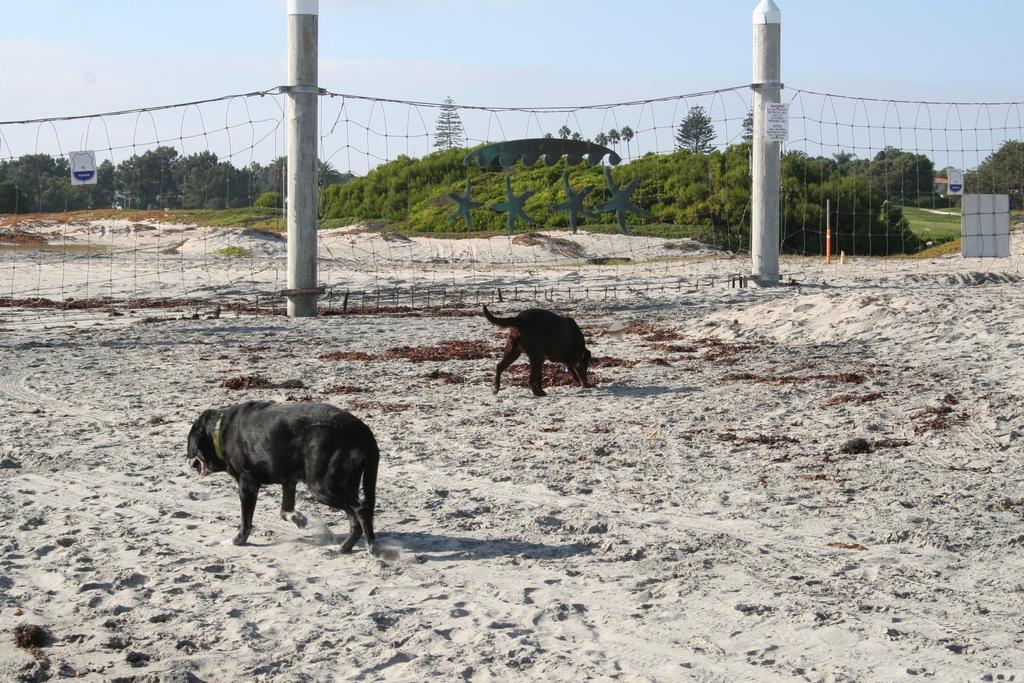Could you give a brief overview of what you see in this image? In the image there are two dogs walking on the sand with a net in front of them and in the background there are trees and above its sky. 